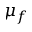<formula> <loc_0><loc_0><loc_500><loc_500>\mu _ { f }</formula> 